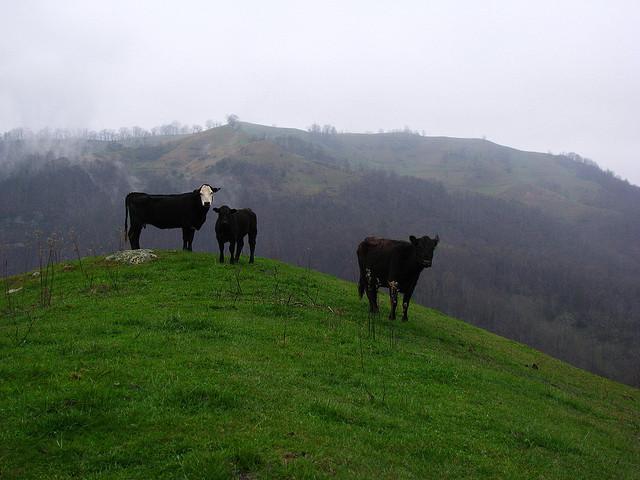How many cows?
Give a very brief answer. 3. How many cows are there?
Give a very brief answer. 3. How many cows in the field?
Give a very brief answer. 3. How many pairs of cow ears are visible?
Give a very brief answer. 3. How many cows can you see?
Give a very brief answer. 2. 